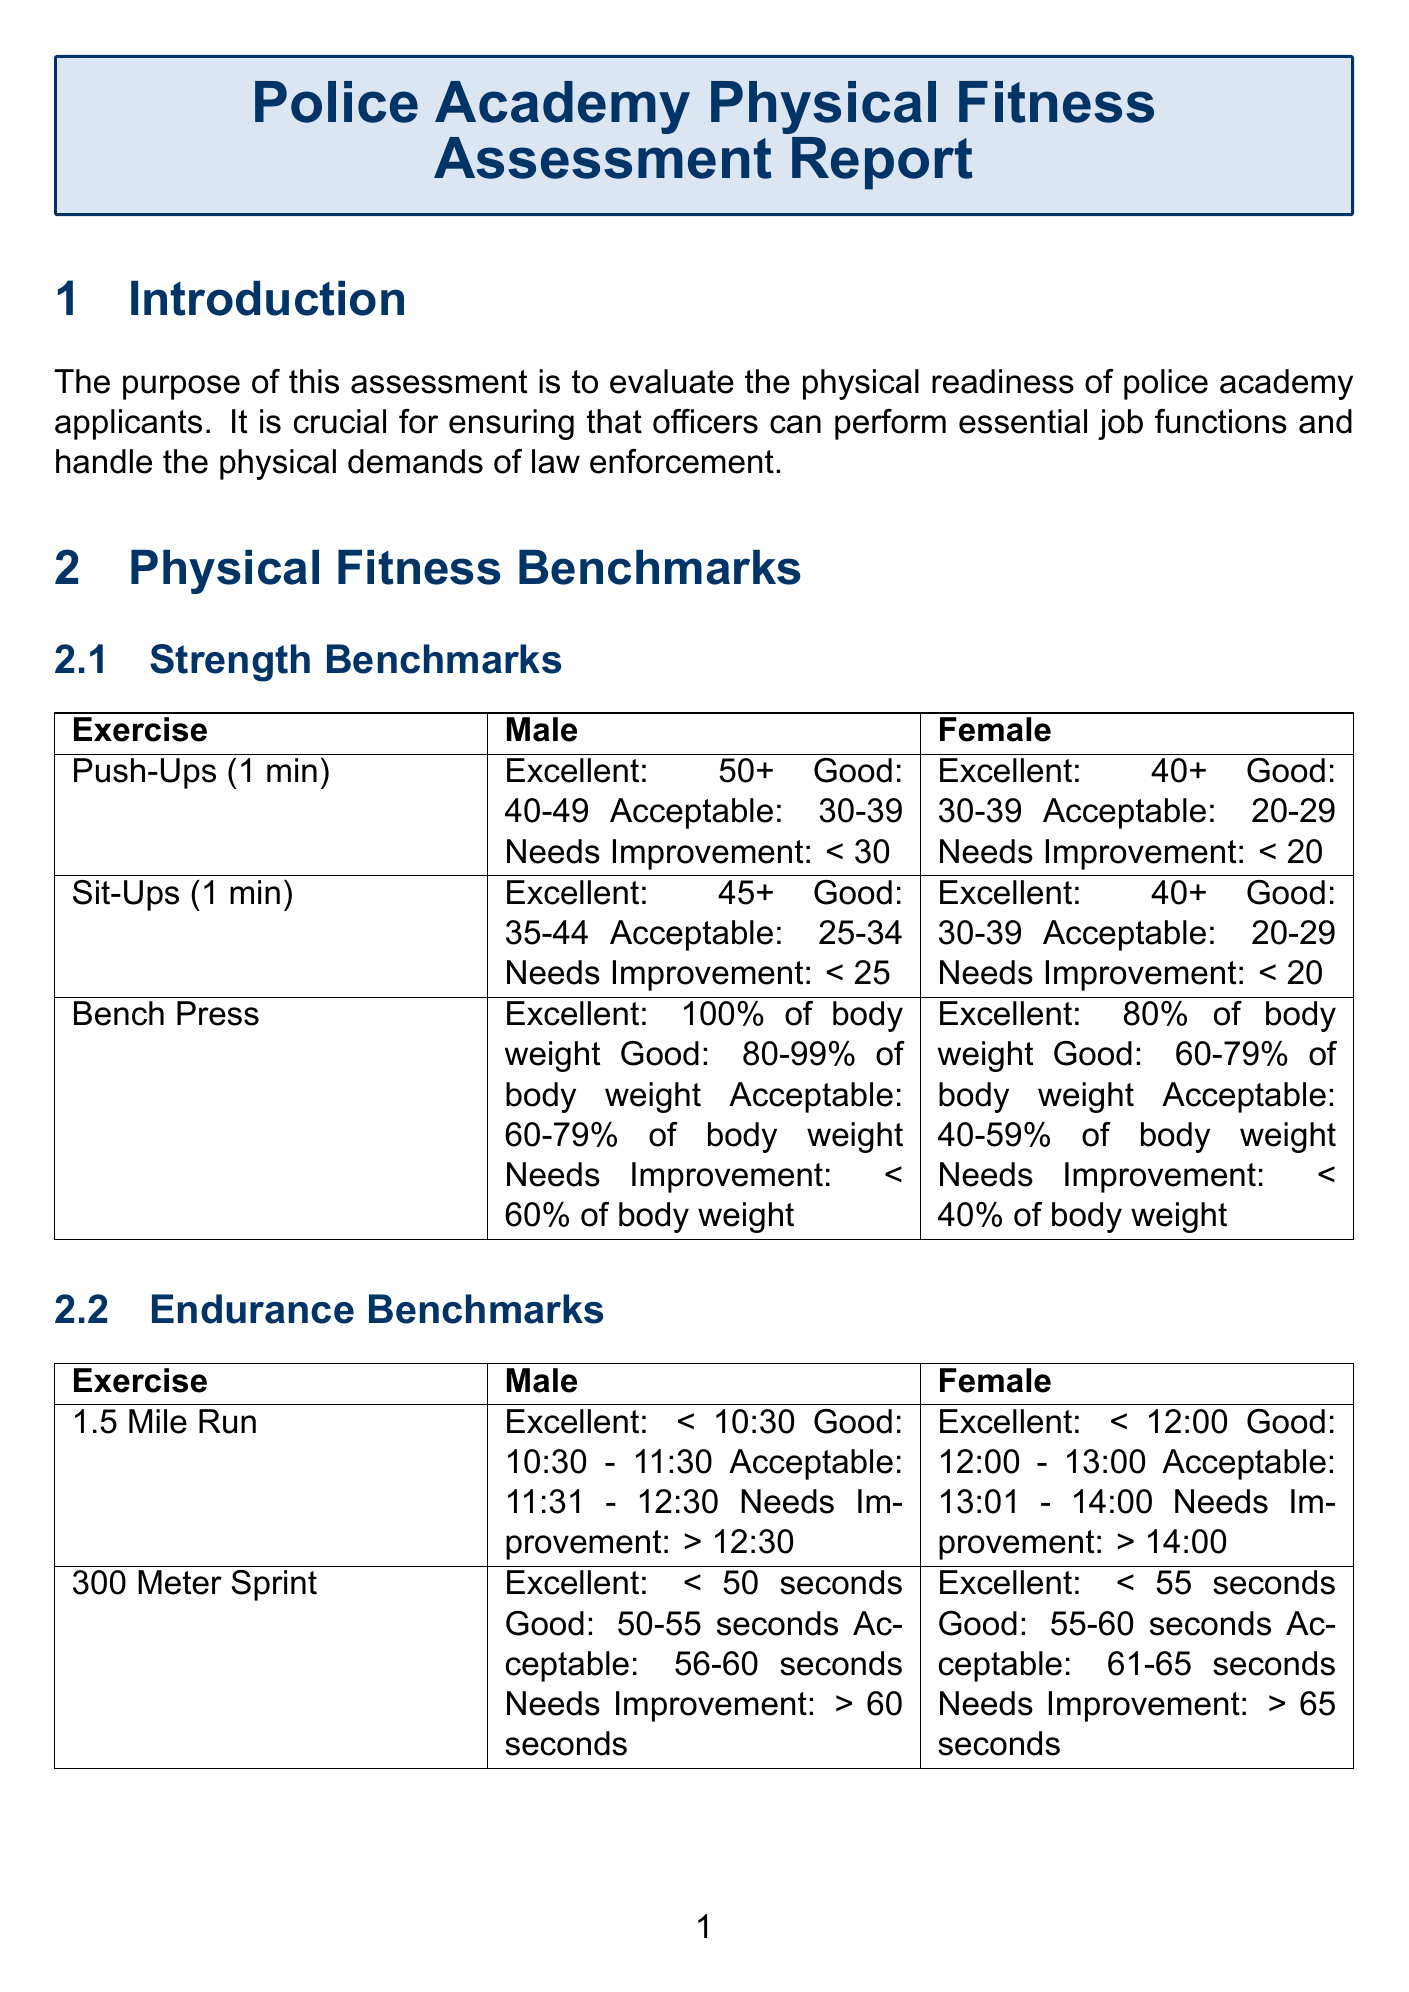What is the purpose of the assessment? The purpose of the assessment is outlined in the introduction section and aims to evaluate police academy applicants' physical readiness.
Answer: To evaluate the physical readiness of police academy applicants What are the female push-ups benchmarks for 'acceptable'? The push-ups benchmarks for females are detailed in the strength benchmarks section of the document.
Answer: 20-29 in 1 minute What is the excellent benchmark for the 1.5-mile run for males? The excellent benchmark for the 1.5-mile run is specified under the endurance benchmarks section.
Answer: < 10:30 What is one common challenge faced during preparation? Common challenges are listed in a specific section of the document, which discusses issues faced by applicants.
Answer: Balancing strength and endurance training How many times per week should strength training be incorporated? The preparation tips include specific recommendations for the frequency of strength training in the strength training subsection.
Answer: 3-4 times per week What online program is mentioned for fitness training preparation? The resources for preparation section lists various programs, and one online program is specified.
Answer: NYPD Candidate Assessment Program What exercise is used in the Illinois Agility Test? The agility benchmarks section describes specific exercises that applicants must complete, including the one referred to in the question.
Answer: Illinois Agility Test What is the adequate benchmark for vertical jump for females? The benchmarks for the vertical jump are provided in the agility benchmarks section, specifically for females.
Answer: > 16 inches 